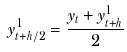Convert formula to latex. <formula><loc_0><loc_0><loc_500><loc_500>y _ { t + h / 2 } ^ { 1 } = \frac { y _ { t } + y _ { t + h } ^ { 1 } } { 2 }</formula> 